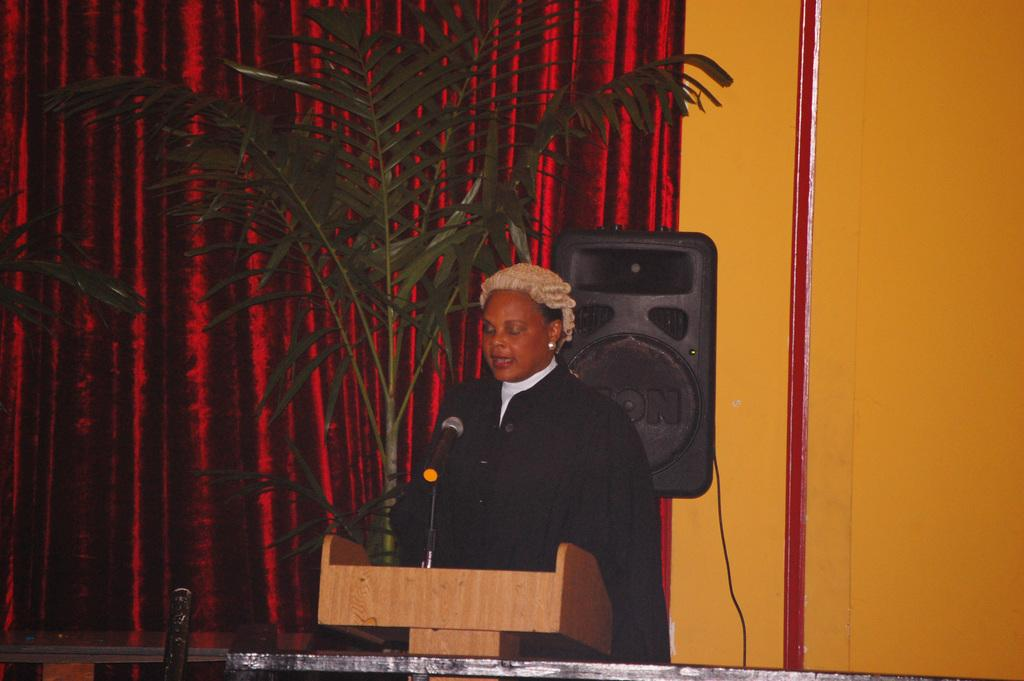Who or what is in the image? There is a person in the image. What object is the person standing near? There is a podium in the image. What device is visible near the person? A microphone (mic) is present in the image. What type of vegetation is in the image? There is a plant in the image. What can be seen in the background of the image? There is a curtain in the background of the image. What language is the person speaking in the image? The image does not provide any information about the language being spoken. Is there any fog visible in the image? There is no fog present in the image. 